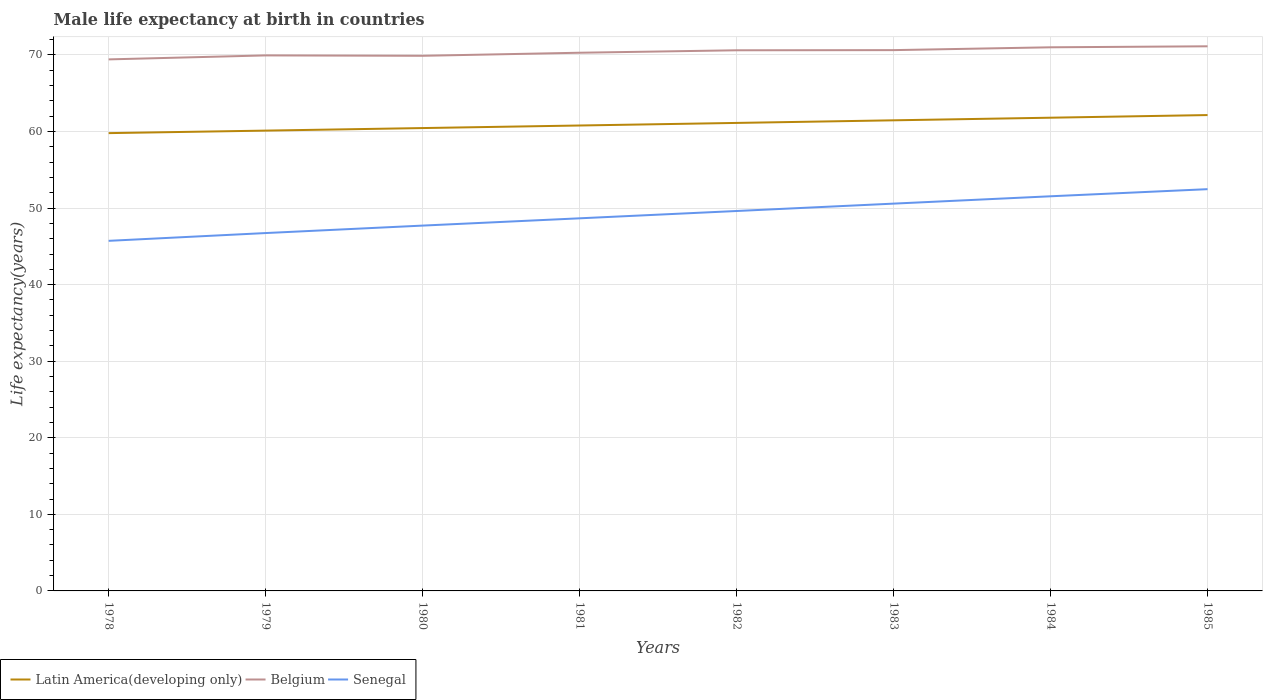Does the line corresponding to Belgium intersect with the line corresponding to Latin America(developing only)?
Give a very brief answer. No. Across all years, what is the maximum male life expectancy at birth in Latin America(developing only)?
Provide a short and direct response. 59.79. In which year was the male life expectancy at birth in Belgium maximum?
Ensure brevity in your answer.  1978. What is the total male life expectancy at birth in Senegal in the graph?
Provide a short and direct response. -5.82. What is the difference between the highest and the second highest male life expectancy at birth in Latin America(developing only)?
Give a very brief answer. 2.36. What is the difference between the highest and the lowest male life expectancy at birth in Latin America(developing only)?
Your answer should be compact. 4. How many years are there in the graph?
Provide a short and direct response. 8. What is the difference between two consecutive major ticks on the Y-axis?
Your response must be concise. 10. Are the values on the major ticks of Y-axis written in scientific E-notation?
Give a very brief answer. No. Does the graph contain any zero values?
Ensure brevity in your answer.  No. Does the graph contain grids?
Provide a succinct answer. Yes. Where does the legend appear in the graph?
Your answer should be compact. Bottom left. How many legend labels are there?
Ensure brevity in your answer.  3. How are the legend labels stacked?
Give a very brief answer. Horizontal. What is the title of the graph?
Offer a very short reply. Male life expectancy at birth in countries. Does "Cote d'Ivoire" appear as one of the legend labels in the graph?
Make the answer very short. No. What is the label or title of the Y-axis?
Your answer should be compact. Life expectancy(years). What is the Life expectancy(years) of Latin America(developing only) in 1978?
Offer a terse response. 59.79. What is the Life expectancy(years) of Belgium in 1978?
Ensure brevity in your answer.  69.42. What is the Life expectancy(years) in Senegal in 1978?
Ensure brevity in your answer.  45.72. What is the Life expectancy(years) in Latin America(developing only) in 1979?
Keep it short and to the point. 60.12. What is the Life expectancy(years) in Belgium in 1979?
Ensure brevity in your answer.  69.94. What is the Life expectancy(years) of Senegal in 1979?
Provide a short and direct response. 46.74. What is the Life expectancy(years) of Latin America(developing only) in 1980?
Ensure brevity in your answer.  60.45. What is the Life expectancy(years) in Belgium in 1980?
Keep it short and to the point. 69.89. What is the Life expectancy(years) in Senegal in 1980?
Give a very brief answer. 47.71. What is the Life expectancy(years) in Latin America(developing only) in 1981?
Give a very brief answer. 60.79. What is the Life expectancy(years) in Belgium in 1981?
Offer a very short reply. 70.29. What is the Life expectancy(years) of Senegal in 1981?
Make the answer very short. 48.66. What is the Life expectancy(years) in Latin America(developing only) in 1982?
Your answer should be compact. 61.12. What is the Life expectancy(years) of Belgium in 1982?
Ensure brevity in your answer.  70.61. What is the Life expectancy(years) in Senegal in 1982?
Your answer should be compact. 49.62. What is the Life expectancy(years) in Latin America(developing only) in 1983?
Provide a succinct answer. 61.46. What is the Life expectancy(years) in Belgium in 1983?
Provide a short and direct response. 70.63. What is the Life expectancy(years) of Senegal in 1983?
Make the answer very short. 50.58. What is the Life expectancy(years) of Latin America(developing only) in 1984?
Make the answer very short. 61.81. What is the Life expectancy(years) of Belgium in 1984?
Give a very brief answer. 71. What is the Life expectancy(years) in Senegal in 1984?
Your response must be concise. 51.54. What is the Life expectancy(years) in Latin America(developing only) in 1985?
Your answer should be compact. 62.15. What is the Life expectancy(years) in Belgium in 1985?
Keep it short and to the point. 71.13. What is the Life expectancy(years) of Senegal in 1985?
Your answer should be compact. 52.47. Across all years, what is the maximum Life expectancy(years) in Latin America(developing only)?
Your answer should be compact. 62.15. Across all years, what is the maximum Life expectancy(years) of Belgium?
Your answer should be compact. 71.13. Across all years, what is the maximum Life expectancy(years) in Senegal?
Offer a very short reply. 52.47. Across all years, what is the minimum Life expectancy(years) in Latin America(developing only)?
Your answer should be compact. 59.79. Across all years, what is the minimum Life expectancy(years) in Belgium?
Offer a terse response. 69.42. Across all years, what is the minimum Life expectancy(years) of Senegal?
Make the answer very short. 45.72. What is the total Life expectancy(years) in Latin America(developing only) in the graph?
Keep it short and to the point. 487.69. What is the total Life expectancy(years) of Belgium in the graph?
Your answer should be compact. 562.91. What is the total Life expectancy(years) of Senegal in the graph?
Make the answer very short. 393.05. What is the difference between the Life expectancy(years) in Latin America(developing only) in 1978 and that in 1979?
Offer a very short reply. -0.33. What is the difference between the Life expectancy(years) of Belgium in 1978 and that in 1979?
Offer a terse response. -0.52. What is the difference between the Life expectancy(years) of Senegal in 1978 and that in 1979?
Your response must be concise. -1.02. What is the difference between the Life expectancy(years) in Latin America(developing only) in 1978 and that in 1980?
Your response must be concise. -0.66. What is the difference between the Life expectancy(years) of Belgium in 1978 and that in 1980?
Offer a terse response. -0.47. What is the difference between the Life expectancy(years) in Senegal in 1978 and that in 1980?
Offer a very short reply. -1.99. What is the difference between the Life expectancy(years) of Latin America(developing only) in 1978 and that in 1981?
Offer a very short reply. -1. What is the difference between the Life expectancy(years) in Belgium in 1978 and that in 1981?
Keep it short and to the point. -0.87. What is the difference between the Life expectancy(years) of Senegal in 1978 and that in 1981?
Give a very brief answer. -2.94. What is the difference between the Life expectancy(years) of Latin America(developing only) in 1978 and that in 1982?
Your answer should be compact. -1.33. What is the difference between the Life expectancy(years) in Belgium in 1978 and that in 1982?
Your response must be concise. -1.19. What is the difference between the Life expectancy(years) in Senegal in 1978 and that in 1982?
Give a very brief answer. -3.9. What is the difference between the Life expectancy(years) of Latin America(developing only) in 1978 and that in 1983?
Keep it short and to the point. -1.67. What is the difference between the Life expectancy(years) of Belgium in 1978 and that in 1983?
Your response must be concise. -1.21. What is the difference between the Life expectancy(years) of Senegal in 1978 and that in 1983?
Keep it short and to the point. -4.86. What is the difference between the Life expectancy(years) of Latin America(developing only) in 1978 and that in 1984?
Make the answer very short. -2.02. What is the difference between the Life expectancy(years) of Belgium in 1978 and that in 1984?
Make the answer very short. -1.58. What is the difference between the Life expectancy(years) in Senegal in 1978 and that in 1984?
Your answer should be very brief. -5.82. What is the difference between the Life expectancy(years) in Latin America(developing only) in 1978 and that in 1985?
Offer a very short reply. -2.36. What is the difference between the Life expectancy(years) in Belgium in 1978 and that in 1985?
Make the answer very short. -1.71. What is the difference between the Life expectancy(years) in Senegal in 1978 and that in 1985?
Keep it short and to the point. -6.75. What is the difference between the Life expectancy(years) in Latin America(developing only) in 1979 and that in 1980?
Provide a succinct answer. -0.33. What is the difference between the Life expectancy(years) in Senegal in 1979 and that in 1980?
Provide a short and direct response. -0.97. What is the difference between the Life expectancy(years) of Latin America(developing only) in 1979 and that in 1981?
Keep it short and to the point. -0.67. What is the difference between the Life expectancy(years) in Belgium in 1979 and that in 1981?
Provide a succinct answer. -0.35. What is the difference between the Life expectancy(years) in Senegal in 1979 and that in 1981?
Your answer should be compact. -1.93. What is the difference between the Life expectancy(years) of Latin America(developing only) in 1979 and that in 1982?
Your answer should be compact. -1.01. What is the difference between the Life expectancy(years) in Belgium in 1979 and that in 1982?
Your answer should be very brief. -0.67. What is the difference between the Life expectancy(years) of Senegal in 1979 and that in 1982?
Your answer should be very brief. -2.88. What is the difference between the Life expectancy(years) of Latin America(developing only) in 1979 and that in 1983?
Ensure brevity in your answer.  -1.34. What is the difference between the Life expectancy(years) of Belgium in 1979 and that in 1983?
Your answer should be very brief. -0.69. What is the difference between the Life expectancy(years) of Senegal in 1979 and that in 1983?
Provide a short and direct response. -3.84. What is the difference between the Life expectancy(years) of Latin America(developing only) in 1979 and that in 1984?
Your response must be concise. -1.69. What is the difference between the Life expectancy(years) of Belgium in 1979 and that in 1984?
Your answer should be very brief. -1.06. What is the difference between the Life expectancy(years) in Senegal in 1979 and that in 1984?
Your answer should be very brief. -4.8. What is the difference between the Life expectancy(years) of Latin America(developing only) in 1979 and that in 1985?
Offer a very short reply. -2.03. What is the difference between the Life expectancy(years) of Belgium in 1979 and that in 1985?
Provide a short and direct response. -1.19. What is the difference between the Life expectancy(years) in Senegal in 1979 and that in 1985?
Make the answer very short. -5.73. What is the difference between the Life expectancy(years) in Latin America(developing only) in 1980 and that in 1981?
Offer a terse response. -0.34. What is the difference between the Life expectancy(years) of Senegal in 1980 and that in 1981?
Offer a very short reply. -0.95. What is the difference between the Life expectancy(years) in Latin America(developing only) in 1980 and that in 1982?
Give a very brief answer. -0.67. What is the difference between the Life expectancy(years) in Belgium in 1980 and that in 1982?
Your response must be concise. -0.72. What is the difference between the Life expectancy(years) of Senegal in 1980 and that in 1982?
Give a very brief answer. -1.91. What is the difference between the Life expectancy(years) in Latin America(developing only) in 1980 and that in 1983?
Ensure brevity in your answer.  -1.01. What is the difference between the Life expectancy(years) of Belgium in 1980 and that in 1983?
Your response must be concise. -0.74. What is the difference between the Life expectancy(years) of Senegal in 1980 and that in 1983?
Your answer should be compact. -2.87. What is the difference between the Life expectancy(years) in Latin America(developing only) in 1980 and that in 1984?
Give a very brief answer. -1.35. What is the difference between the Life expectancy(years) of Belgium in 1980 and that in 1984?
Provide a succinct answer. -1.11. What is the difference between the Life expectancy(years) in Senegal in 1980 and that in 1984?
Ensure brevity in your answer.  -3.83. What is the difference between the Life expectancy(years) in Latin America(developing only) in 1980 and that in 1985?
Keep it short and to the point. -1.7. What is the difference between the Life expectancy(years) of Belgium in 1980 and that in 1985?
Make the answer very short. -1.24. What is the difference between the Life expectancy(years) in Senegal in 1980 and that in 1985?
Keep it short and to the point. -4.76. What is the difference between the Life expectancy(years) in Latin America(developing only) in 1981 and that in 1982?
Ensure brevity in your answer.  -0.34. What is the difference between the Life expectancy(years) in Belgium in 1981 and that in 1982?
Provide a short and direct response. -0.32. What is the difference between the Life expectancy(years) of Senegal in 1981 and that in 1982?
Provide a succinct answer. -0.95. What is the difference between the Life expectancy(years) of Latin America(developing only) in 1981 and that in 1983?
Provide a succinct answer. -0.68. What is the difference between the Life expectancy(years) in Belgium in 1981 and that in 1983?
Offer a terse response. -0.34. What is the difference between the Life expectancy(years) in Senegal in 1981 and that in 1983?
Your answer should be compact. -1.92. What is the difference between the Life expectancy(years) in Latin America(developing only) in 1981 and that in 1984?
Your answer should be compact. -1.02. What is the difference between the Life expectancy(years) of Belgium in 1981 and that in 1984?
Provide a succinct answer. -0.71. What is the difference between the Life expectancy(years) in Senegal in 1981 and that in 1984?
Give a very brief answer. -2.88. What is the difference between the Life expectancy(years) of Latin America(developing only) in 1981 and that in 1985?
Keep it short and to the point. -1.36. What is the difference between the Life expectancy(years) of Belgium in 1981 and that in 1985?
Keep it short and to the point. -0.84. What is the difference between the Life expectancy(years) in Senegal in 1981 and that in 1985?
Your response must be concise. -3.81. What is the difference between the Life expectancy(years) of Latin America(developing only) in 1982 and that in 1983?
Keep it short and to the point. -0.34. What is the difference between the Life expectancy(years) of Belgium in 1982 and that in 1983?
Your answer should be compact. -0.02. What is the difference between the Life expectancy(years) in Senegal in 1982 and that in 1983?
Your answer should be very brief. -0.96. What is the difference between the Life expectancy(years) in Latin America(developing only) in 1982 and that in 1984?
Your answer should be very brief. -0.68. What is the difference between the Life expectancy(years) in Belgium in 1982 and that in 1984?
Offer a very short reply. -0.39. What is the difference between the Life expectancy(years) in Senegal in 1982 and that in 1984?
Your answer should be compact. -1.92. What is the difference between the Life expectancy(years) of Latin America(developing only) in 1982 and that in 1985?
Your answer should be very brief. -1.02. What is the difference between the Life expectancy(years) of Belgium in 1982 and that in 1985?
Offer a very short reply. -0.52. What is the difference between the Life expectancy(years) in Senegal in 1982 and that in 1985?
Provide a succinct answer. -2.85. What is the difference between the Life expectancy(years) in Latin America(developing only) in 1983 and that in 1984?
Provide a short and direct response. -0.34. What is the difference between the Life expectancy(years) of Belgium in 1983 and that in 1984?
Offer a very short reply. -0.37. What is the difference between the Life expectancy(years) in Senegal in 1983 and that in 1984?
Your answer should be very brief. -0.96. What is the difference between the Life expectancy(years) in Latin America(developing only) in 1983 and that in 1985?
Your answer should be compact. -0.69. What is the difference between the Life expectancy(years) of Senegal in 1983 and that in 1985?
Keep it short and to the point. -1.89. What is the difference between the Life expectancy(years) of Latin America(developing only) in 1984 and that in 1985?
Your response must be concise. -0.34. What is the difference between the Life expectancy(years) of Belgium in 1984 and that in 1985?
Provide a short and direct response. -0.13. What is the difference between the Life expectancy(years) in Senegal in 1984 and that in 1985?
Provide a short and direct response. -0.93. What is the difference between the Life expectancy(years) of Latin America(developing only) in 1978 and the Life expectancy(years) of Belgium in 1979?
Keep it short and to the point. -10.15. What is the difference between the Life expectancy(years) in Latin America(developing only) in 1978 and the Life expectancy(years) in Senegal in 1979?
Keep it short and to the point. 13.05. What is the difference between the Life expectancy(years) in Belgium in 1978 and the Life expectancy(years) in Senegal in 1979?
Your response must be concise. 22.68. What is the difference between the Life expectancy(years) of Latin America(developing only) in 1978 and the Life expectancy(years) of Belgium in 1980?
Provide a succinct answer. -10.1. What is the difference between the Life expectancy(years) in Latin America(developing only) in 1978 and the Life expectancy(years) in Senegal in 1980?
Your response must be concise. 12.08. What is the difference between the Life expectancy(years) of Belgium in 1978 and the Life expectancy(years) of Senegal in 1980?
Keep it short and to the point. 21.71. What is the difference between the Life expectancy(years) of Latin America(developing only) in 1978 and the Life expectancy(years) of Belgium in 1981?
Your answer should be compact. -10.5. What is the difference between the Life expectancy(years) of Latin America(developing only) in 1978 and the Life expectancy(years) of Senegal in 1981?
Give a very brief answer. 11.12. What is the difference between the Life expectancy(years) in Belgium in 1978 and the Life expectancy(years) in Senegal in 1981?
Make the answer very short. 20.75. What is the difference between the Life expectancy(years) in Latin America(developing only) in 1978 and the Life expectancy(years) in Belgium in 1982?
Offer a very short reply. -10.82. What is the difference between the Life expectancy(years) of Latin America(developing only) in 1978 and the Life expectancy(years) of Senegal in 1982?
Provide a succinct answer. 10.17. What is the difference between the Life expectancy(years) of Belgium in 1978 and the Life expectancy(years) of Senegal in 1982?
Offer a very short reply. 19.8. What is the difference between the Life expectancy(years) of Latin America(developing only) in 1978 and the Life expectancy(years) of Belgium in 1983?
Your answer should be compact. -10.84. What is the difference between the Life expectancy(years) in Latin America(developing only) in 1978 and the Life expectancy(years) in Senegal in 1983?
Offer a very short reply. 9.21. What is the difference between the Life expectancy(years) in Belgium in 1978 and the Life expectancy(years) in Senegal in 1983?
Ensure brevity in your answer.  18.84. What is the difference between the Life expectancy(years) of Latin America(developing only) in 1978 and the Life expectancy(years) of Belgium in 1984?
Ensure brevity in your answer.  -11.21. What is the difference between the Life expectancy(years) of Latin America(developing only) in 1978 and the Life expectancy(years) of Senegal in 1984?
Your answer should be very brief. 8.25. What is the difference between the Life expectancy(years) of Belgium in 1978 and the Life expectancy(years) of Senegal in 1984?
Your response must be concise. 17.88. What is the difference between the Life expectancy(years) in Latin America(developing only) in 1978 and the Life expectancy(years) in Belgium in 1985?
Offer a very short reply. -11.34. What is the difference between the Life expectancy(years) of Latin America(developing only) in 1978 and the Life expectancy(years) of Senegal in 1985?
Ensure brevity in your answer.  7.32. What is the difference between the Life expectancy(years) of Belgium in 1978 and the Life expectancy(years) of Senegal in 1985?
Ensure brevity in your answer.  16.95. What is the difference between the Life expectancy(years) in Latin America(developing only) in 1979 and the Life expectancy(years) in Belgium in 1980?
Your response must be concise. -9.77. What is the difference between the Life expectancy(years) in Latin America(developing only) in 1979 and the Life expectancy(years) in Senegal in 1980?
Offer a terse response. 12.41. What is the difference between the Life expectancy(years) in Belgium in 1979 and the Life expectancy(years) in Senegal in 1980?
Your answer should be very brief. 22.23. What is the difference between the Life expectancy(years) in Latin America(developing only) in 1979 and the Life expectancy(years) in Belgium in 1981?
Your answer should be compact. -10.17. What is the difference between the Life expectancy(years) of Latin America(developing only) in 1979 and the Life expectancy(years) of Senegal in 1981?
Provide a succinct answer. 11.45. What is the difference between the Life expectancy(years) of Belgium in 1979 and the Life expectancy(years) of Senegal in 1981?
Provide a succinct answer. 21.27. What is the difference between the Life expectancy(years) in Latin America(developing only) in 1979 and the Life expectancy(years) in Belgium in 1982?
Your answer should be compact. -10.49. What is the difference between the Life expectancy(years) in Latin America(developing only) in 1979 and the Life expectancy(years) in Senegal in 1982?
Your answer should be very brief. 10.5. What is the difference between the Life expectancy(years) of Belgium in 1979 and the Life expectancy(years) of Senegal in 1982?
Make the answer very short. 20.32. What is the difference between the Life expectancy(years) of Latin America(developing only) in 1979 and the Life expectancy(years) of Belgium in 1983?
Ensure brevity in your answer.  -10.51. What is the difference between the Life expectancy(years) in Latin America(developing only) in 1979 and the Life expectancy(years) in Senegal in 1983?
Give a very brief answer. 9.54. What is the difference between the Life expectancy(years) in Belgium in 1979 and the Life expectancy(years) in Senegal in 1983?
Ensure brevity in your answer.  19.36. What is the difference between the Life expectancy(years) in Latin America(developing only) in 1979 and the Life expectancy(years) in Belgium in 1984?
Give a very brief answer. -10.88. What is the difference between the Life expectancy(years) of Latin America(developing only) in 1979 and the Life expectancy(years) of Senegal in 1984?
Provide a short and direct response. 8.58. What is the difference between the Life expectancy(years) of Belgium in 1979 and the Life expectancy(years) of Senegal in 1984?
Offer a very short reply. 18.4. What is the difference between the Life expectancy(years) in Latin America(developing only) in 1979 and the Life expectancy(years) in Belgium in 1985?
Provide a short and direct response. -11.01. What is the difference between the Life expectancy(years) in Latin America(developing only) in 1979 and the Life expectancy(years) in Senegal in 1985?
Provide a short and direct response. 7.65. What is the difference between the Life expectancy(years) in Belgium in 1979 and the Life expectancy(years) in Senegal in 1985?
Ensure brevity in your answer.  17.47. What is the difference between the Life expectancy(years) of Latin America(developing only) in 1980 and the Life expectancy(years) of Belgium in 1981?
Ensure brevity in your answer.  -9.84. What is the difference between the Life expectancy(years) of Latin America(developing only) in 1980 and the Life expectancy(years) of Senegal in 1981?
Offer a terse response. 11.79. What is the difference between the Life expectancy(years) in Belgium in 1980 and the Life expectancy(years) in Senegal in 1981?
Your answer should be very brief. 21.23. What is the difference between the Life expectancy(years) of Latin America(developing only) in 1980 and the Life expectancy(years) of Belgium in 1982?
Ensure brevity in your answer.  -10.16. What is the difference between the Life expectancy(years) in Latin America(developing only) in 1980 and the Life expectancy(years) in Senegal in 1982?
Provide a short and direct response. 10.83. What is the difference between the Life expectancy(years) of Belgium in 1980 and the Life expectancy(years) of Senegal in 1982?
Offer a very short reply. 20.27. What is the difference between the Life expectancy(years) in Latin America(developing only) in 1980 and the Life expectancy(years) in Belgium in 1983?
Provide a short and direct response. -10.18. What is the difference between the Life expectancy(years) in Latin America(developing only) in 1980 and the Life expectancy(years) in Senegal in 1983?
Offer a terse response. 9.87. What is the difference between the Life expectancy(years) in Belgium in 1980 and the Life expectancy(years) in Senegal in 1983?
Give a very brief answer. 19.31. What is the difference between the Life expectancy(years) in Latin America(developing only) in 1980 and the Life expectancy(years) in Belgium in 1984?
Give a very brief answer. -10.55. What is the difference between the Life expectancy(years) in Latin America(developing only) in 1980 and the Life expectancy(years) in Senegal in 1984?
Offer a very short reply. 8.91. What is the difference between the Life expectancy(years) of Belgium in 1980 and the Life expectancy(years) of Senegal in 1984?
Make the answer very short. 18.35. What is the difference between the Life expectancy(years) of Latin America(developing only) in 1980 and the Life expectancy(years) of Belgium in 1985?
Keep it short and to the point. -10.68. What is the difference between the Life expectancy(years) of Latin America(developing only) in 1980 and the Life expectancy(years) of Senegal in 1985?
Offer a very short reply. 7.98. What is the difference between the Life expectancy(years) of Belgium in 1980 and the Life expectancy(years) of Senegal in 1985?
Your answer should be compact. 17.42. What is the difference between the Life expectancy(years) in Latin America(developing only) in 1981 and the Life expectancy(years) in Belgium in 1982?
Give a very brief answer. -9.82. What is the difference between the Life expectancy(years) of Latin America(developing only) in 1981 and the Life expectancy(years) of Senegal in 1982?
Offer a terse response. 11.17. What is the difference between the Life expectancy(years) in Belgium in 1981 and the Life expectancy(years) in Senegal in 1982?
Your answer should be compact. 20.67. What is the difference between the Life expectancy(years) of Latin America(developing only) in 1981 and the Life expectancy(years) of Belgium in 1983?
Provide a succinct answer. -9.84. What is the difference between the Life expectancy(years) in Latin America(developing only) in 1981 and the Life expectancy(years) in Senegal in 1983?
Offer a very short reply. 10.2. What is the difference between the Life expectancy(years) in Belgium in 1981 and the Life expectancy(years) in Senegal in 1983?
Your response must be concise. 19.71. What is the difference between the Life expectancy(years) of Latin America(developing only) in 1981 and the Life expectancy(years) of Belgium in 1984?
Ensure brevity in your answer.  -10.21. What is the difference between the Life expectancy(years) of Latin America(developing only) in 1981 and the Life expectancy(years) of Senegal in 1984?
Keep it short and to the point. 9.24. What is the difference between the Life expectancy(years) of Belgium in 1981 and the Life expectancy(years) of Senegal in 1984?
Provide a short and direct response. 18.75. What is the difference between the Life expectancy(years) in Latin America(developing only) in 1981 and the Life expectancy(years) in Belgium in 1985?
Provide a short and direct response. -10.34. What is the difference between the Life expectancy(years) of Latin America(developing only) in 1981 and the Life expectancy(years) of Senegal in 1985?
Provide a succinct answer. 8.32. What is the difference between the Life expectancy(years) in Belgium in 1981 and the Life expectancy(years) in Senegal in 1985?
Make the answer very short. 17.82. What is the difference between the Life expectancy(years) in Latin America(developing only) in 1982 and the Life expectancy(years) in Belgium in 1983?
Make the answer very short. -9.51. What is the difference between the Life expectancy(years) of Latin America(developing only) in 1982 and the Life expectancy(years) of Senegal in 1983?
Keep it short and to the point. 10.54. What is the difference between the Life expectancy(years) of Belgium in 1982 and the Life expectancy(years) of Senegal in 1983?
Make the answer very short. 20.03. What is the difference between the Life expectancy(years) in Latin America(developing only) in 1982 and the Life expectancy(years) in Belgium in 1984?
Offer a very short reply. -9.88. What is the difference between the Life expectancy(years) of Latin America(developing only) in 1982 and the Life expectancy(years) of Senegal in 1984?
Offer a terse response. 9.58. What is the difference between the Life expectancy(years) of Belgium in 1982 and the Life expectancy(years) of Senegal in 1984?
Ensure brevity in your answer.  19.07. What is the difference between the Life expectancy(years) of Latin America(developing only) in 1982 and the Life expectancy(years) of Belgium in 1985?
Provide a succinct answer. -10.01. What is the difference between the Life expectancy(years) in Latin America(developing only) in 1982 and the Life expectancy(years) in Senegal in 1985?
Provide a succinct answer. 8.65. What is the difference between the Life expectancy(years) in Belgium in 1982 and the Life expectancy(years) in Senegal in 1985?
Offer a very short reply. 18.14. What is the difference between the Life expectancy(years) in Latin America(developing only) in 1983 and the Life expectancy(years) in Belgium in 1984?
Make the answer very short. -9.54. What is the difference between the Life expectancy(years) of Latin America(developing only) in 1983 and the Life expectancy(years) of Senegal in 1984?
Make the answer very short. 9.92. What is the difference between the Life expectancy(years) in Belgium in 1983 and the Life expectancy(years) in Senegal in 1984?
Your response must be concise. 19.09. What is the difference between the Life expectancy(years) in Latin America(developing only) in 1983 and the Life expectancy(years) in Belgium in 1985?
Ensure brevity in your answer.  -9.67. What is the difference between the Life expectancy(years) of Latin America(developing only) in 1983 and the Life expectancy(years) of Senegal in 1985?
Provide a short and direct response. 8.99. What is the difference between the Life expectancy(years) in Belgium in 1983 and the Life expectancy(years) in Senegal in 1985?
Your answer should be very brief. 18.16. What is the difference between the Life expectancy(years) of Latin America(developing only) in 1984 and the Life expectancy(years) of Belgium in 1985?
Your response must be concise. -9.32. What is the difference between the Life expectancy(years) in Latin America(developing only) in 1984 and the Life expectancy(years) in Senegal in 1985?
Your response must be concise. 9.34. What is the difference between the Life expectancy(years) in Belgium in 1984 and the Life expectancy(years) in Senegal in 1985?
Provide a succinct answer. 18.53. What is the average Life expectancy(years) in Latin America(developing only) per year?
Give a very brief answer. 60.96. What is the average Life expectancy(years) in Belgium per year?
Provide a succinct answer. 70.36. What is the average Life expectancy(years) in Senegal per year?
Provide a succinct answer. 49.13. In the year 1978, what is the difference between the Life expectancy(years) of Latin America(developing only) and Life expectancy(years) of Belgium?
Your answer should be very brief. -9.63. In the year 1978, what is the difference between the Life expectancy(years) of Latin America(developing only) and Life expectancy(years) of Senegal?
Make the answer very short. 14.07. In the year 1978, what is the difference between the Life expectancy(years) in Belgium and Life expectancy(years) in Senegal?
Provide a succinct answer. 23.7. In the year 1979, what is the difference between the Life expectancy(years) in Latin America(developing only) and Life expectancy(years) in Belgium?
Give a very brief answer. -9.82. In the year 1979, what is the difference between the Life expectancy(years) in Latin America(developing only) and Life expectancy(years) in Senegal?
Offer a terse response. 13.38. In the year 1979, what is the difference between the Life expectancy(years) of Belgium and Life expectancy(years) of Senegal?
Keep it short and to the point. 23.2. In the year 1980, what is the difference between the Life expectancy(years) of Latin America(developing only) and Life expectancy(years) of Belgium?
Provide a short and direct response. -9.44. In the year 1980, what is the difference between the Life expectancy(years) in Latin America(developing only) and Life expectancy(years) in Senegal?
Ensure brevity in your answer.  12.74. In the year 1980, what is the difference between the Life expectancy(years) in Belgium and Life expectancy(years) in Senegal?
Offer a terse response. 22.18. In the year 1981, what is the difference between the Life expectancy(years) of Latin America(developing only) and Life expectancy(years) of Belgium?
Your response must be concise. -9.5. In the year 1981, what is the difference between the Life expectancy(years) of Latin America(developing only) and Life expectancy(years) of Senegal?
Keep it short and to the point. 12.12. In the year 1981, what is the difference between the Life expectancy(years) in Belgium and Life expectancy(years) in Senegal?
Your answer should be compact. 21.62. In the year 1982, what is the difference between the Life expectancy(years) of Latin America(developing only) and Life expectancy(years) of Belgium?
Offer a terse response. -9.49. In the year 1982, what is the difference between the Life expectancy(years) in Latin America(developing only) and Life expectancy(years) in Senegal?
Ensure brevity in your answer.  11.51. In the year 1982, what is the difference between the Life expectancy(years) of Belgium and Life expectancy(years) of Senegal?
Make the answer very short. 20.99. In the year 1983, what is the difference between the Life expectancy(years) in Latin America(developing only) and Life expectancy(years) in Belgium?
Your answer should be very brief. -9.17. In the year 1983, what is the difference between the Life expectancy(years) of Latin America(developing only) and Life expectancy(years) of Senegal?
Your response must be concise. 10.88. In the year 1983, what is the difference between the Life expectancy(years) in Belgium and Life expectancy(years) in Senegal?
Offer a very short reply. 20.05. In the year 1984, what is the difference between the Life expectancy(years) in Latin America(developing only) and Life expectancy(years) in Belgium?
Make the answer very short. -9.19. In the year 1984, what is the difference between the Life expectancy(years) of Latin America(developing only) and Life expectancy(years) of Senegal?
Your answer should be compact. 10.26. In the year 1984, what is the difference between the Life expectancy(years) in Belgium and Life expectancy(years) in Senegal?
Provide a short and direct response. 19.46. In the year 1985, what is the difference between the Life expectancy(years) of Latin America(developing only) and Life expectancy(years) of Belgium?
Keep it short and to the point. -8.98. In the year 1985, what is the difference between the Life expectancy(years) of Latin America(developing only) and Life expectancy(years) of Senegal?
Your response must be concise. 9.68. In the year 1985, what is the difference between the Life expectancy(years) of Belgium and Life expectancy(years) of Senegal?
Keep it short and to the point. 18.66. What is the ratio of the Life expectancy(years) in Latin America(developing only) in 1978 to that in 1979?
Ensure brevity in your answer.  0.99. What is the ratio of the Life expectancy(years) in Senegal in 1978 to that in 1979?
Your answer should be compact. 0.98. What is the ratio of the Life expectancy(years) in Latin America(developing only) in 1978 to that in 1980?
Keep it short and to the point. 0.99. What is the ratio of the Life expectancy(years) in Latin America(developing only) in 1978 to that in 1981?
Your answer should be compact. 0.98. What is the ratio of the Life expectancy(years) of Belgium in 1978 to that in 1981?
Your answer should be compact. 0.99. What is the ratio of the Life expectancy(years) of Senegal in 1978 to that in 1981?
Provide a succinct answer. 0.94. What is the ratio of the Life expectancy(years) of Latin America(developing only) in 1978 to that in 1982?
Give a very brief answer. 0.98. What is the ratio of the Life expectancy(years) of Belgium in 1978 to that in 1982?
Keep it short and to the point. 0.98. What is the ratio of the Life expectancy(years) of Senegal in 1978 to that in 1982?
Give a very brief answer. 0.92. What is the ratio of the Life expectancy(years) of Latin America(developing only) in 1978 to that in 1983?
Ensure brevity in your answer.  0.97. What is the ratio of the Life expectancy(years) of Belgium in 1978 to that in 1983?
Give a very brief answer. 0.98. What is the ratio of the Life expectancy(years) in Senegal in 1978 to that in 1983?
Ensure brevity in your answer.  0.9. What is the ratio of the Life expectancy(years) in Latin America(developing only) in 1978 to that in 1984?
Provide a succinct answer. 0.97. What is the ratio of the Life expectancy(years) in Belgium in 1978 to that in 1984?
Offer a very short reply. 0.98. What is the ratio of the Life expectancy(years) of Senegal in 1978 to that in 1984?
Ensure brevity in your answer.  0.89. What is the ratio of the Life expectancy(years) in Latin America(developing only) in 1978 to that in 1985?
Your answer should be compact. 0.96. What is the ratio of the Life expectancy(years) in Belgium in 1978 to that in 1985?
Provide a succinct answer. 0.98. What is the ratio of the Life expectancy(years) in Senegal in 1978 to that in 1985?
Give a very brief answer. 0.87. What is the ratio of the Life expectancy(years) in Belgium in 1979 to that in 1980?
Your answer should be very brief. 1. What is the ratio of the Life expectancy(years) in Senegal in 1979 to that in 1980?
Keep it short and to the point. 0.98. What is the ratio of the Life expectancy(years) in Latin America(developing only) in 1979 to that in 1981?
Provide a succinct answer. 0.99. What is the ratio of the Life expectancy(years) in Senegal in 1979 to that in 1981?
Give a very brief answer. 0.96. What is the ratio of the Life expectancy(years) in Latin America(developing only) in 1979 to that in 1982?
Your answer should be very brief. 0.98. What is the ratio of the Life expectancy(years) of Senegal in 1979 to that in 1982?
Provide a short and direct response. 0.94. What is the ratio of the Life expectancy(years) in Latin America(developing only) in 1979 to that in 1983?
Ensure brevity in your answer.  0.98. What is the ratio of the Life expectancy(years) of Belgium in 1979 to that in 1983?
Make the answer very short. 0.99. What is the ratio of the Life expectancy(years) in Senegal in 1979 to that in 1983?
Your answer should be compact. 0.92. What is the ratio of the Life expectancy(years) in Latin America(developing only) in 1979 to that in 1984?
Offer a very short reply. 0.97. What is the ratio of the Life expectancy(years) in Belgium in 1979 to that in 1984?
Provide a short and direct response. 0.99. What is the ratio of the Life expectancy(years) of Senegal in 1979 to that in 1984?
Your response must be concise. 0.91. What is the ratio of the Life expectancy(years) of Latin America(developing only) in 1979 to that in 1985?
Keep it short and to the point. 0.97. What is the ratio of the Life expectancy(years) of Belgium in 1979 to that in 1985?
Your answer should be compact. 0.98. What is the ratio of the Life expectancy(years) of Senegal in 1979 to that in 1985?
Make the answer very short. 0.89. What is the ratio of the Life expectancy(years) in Belgium in 1980 to that in 1981?
Provide a short and direct response. 0.99. What is the ratio of the Life expectancy(years) in Senegal in 1980 to that in 1981?
Give a very brief answer. 0.98. What is the ratio of the Life expectancy(years) of Senegal in 1980 to that in 1982?
Your answer should be very brief. 0.96. What is the ratio of the Life expectancy(years) of Latin America(developing only) in 1980 to that in 1983?
Your response must be concise. 0.98. What is the ratio of the Life expectancy(years) in Senegal in 1980 to that in 1983?
Offer a terse response. 0.94. What is the ratio of the Life expectancy(years) in Latin America(developing only) in 1980 to that in 1984?
Your answer should be very brief. 0.98. What is the ratio of the Life expectancy(years) of Belgium in 1980 to that in 1984?
Make the answer very short. 0.98. What is the ratio of the Life expectancy(years) in Senegal in 1980 to that in 1984?
Provide a succinct answer. 0.93. What is the ratio of the Life expectancy(years) in Latin America(developing only) in 1980 to that in 1985?
Offer a very short reply. 0.97. What is the ratio of the Life expectancy(years) in Belgium in 1980 to that in 1985?
Keep it short and to the point. 0.98. What is the ratio of the Life expectancy(years) in Senegal in 1980 to that in 1985?
Ensure brevity in your answer.  0.91. What is the ratio of the Life expectancy(years) of Latin America(developing only) in 1981 to that in 1982?
Provide a short and direct response. 0.99. What is the ratio of the Life expectancy(years) of Belgium in 1981 to that in 1982?
Make the answer very short. 1. What is the ratio of the Life expectancy(years) in Senegal in 1981 to that in 1982?
Make the answer very short. 0.98. What is the ratio of the Life expectancy(years) in Latin America(developing only) in 1981 to that in 1983?
Offer a terse response. 0.99. What is the ratio of the Life expectancy(years) in Senegal in 1981 to that in 1983?
Provide a short and direct response. 0.96. What is the ratio of the Life expectancy(years) of Latin America(developing only) in 1981 to that in 1984?
Offer a terse response. 0.98. What is the ratio of the Life expectancy(years) in Senegal in 1981 to that in 1984?
Give a very brief answer. 0.94. What is the ratio of the Life expectancy(years) of Latin America(developing only) in 1981 to that in 1985?
Your response must be concise. 0.98. What is the ratio of the Life expectancy(years) in Belgium in 1981 to that in 1985?
Offer a very short reply. 0.99. What is the ratio of the Life expectancy(years) in Senegal in 1981 to that in 1985?
Give a very brief answer. 0.93. What is the ratio of the Life expectancy(years) in Senegal in 1982 to that in 1983?
Give a very brief answer. 0.98. What is the ratio of the Life expectancy(years) of Latin America(developing only) in 1982 to that in 1984?
Provide a short and direct response. 0.99. What is the ratio of the Life expectancy(years) in Belgium in 1982 to that in 1984?
Offer a very short reply. 0.99. What is the ratio of the Life expectancy(years) of Senegal in 1982 to that in 1984?
Make the answer very short. 0.96. What is the ratio of the Life expectancy(years) of Latin America(developing only) in 1982 to that in 1985?
Your answer should be very brief. 0.98. What is the ratio of the Life expectancy(years) of Belgium in 1982 to that in 1985?
Keep it short and to the point. 0.99. What is the ratio of the Life expectancy(years) of Senegal in 1982 to that in 1985?
Your answer should be compact. 0.95. What is the ratio of the Life expectancy(years) of Latin America(developing only) in 1983 to that in 1984?
Give a very brief answer. 0.99. What is the ratio of the Life expectancy(years) in Senegal in 1983 to that in 1984?
Provide a succinct answer. 0.98. What is the ratio of the Life expectancy(years) in Belgium in 1983 to that in 1985?
Your response must be concise. 0.99. What is the ratio of the Life expectancy(years) of Senegal in 1983 to that in 1985?
Your answer should be very brief. 0.96. What is the ratio of the Life expectancy(years) of Latin America(developing only) in 1984 to that in 1985?
Provide a short and direct response. 0.99. What is the ratio of the Life expectancy(years) in Senegal in 1984 to that in 1985?
Your answer should be very brief. 0.98. What is the difference between the highest and the second highest Life expectancy(years) of Latin America(developing only)?
Offer a very short reply. 0.34. What is the difference between the highest and the second highest Life expectancy(years) of Belgium?
Your answer should be compact. 0.13. What is the difference between the highest and the second highest Life expectancy(years) of Senegal?
Ensure brevity in your answer.  0.93. What is the difference between the highest and the lowest Life expectancy(years) of Latin America(developing only)?
Provide a short and direct response. 2.36. What is the difference between the highest and the lowest Life expectancy(years) in Belgium?
Give a very brief answer. 1.71. What is the difference between the highest and the lowest Life expectancy(years) of Senegal?
Provide a succinct answer. 6.75. 